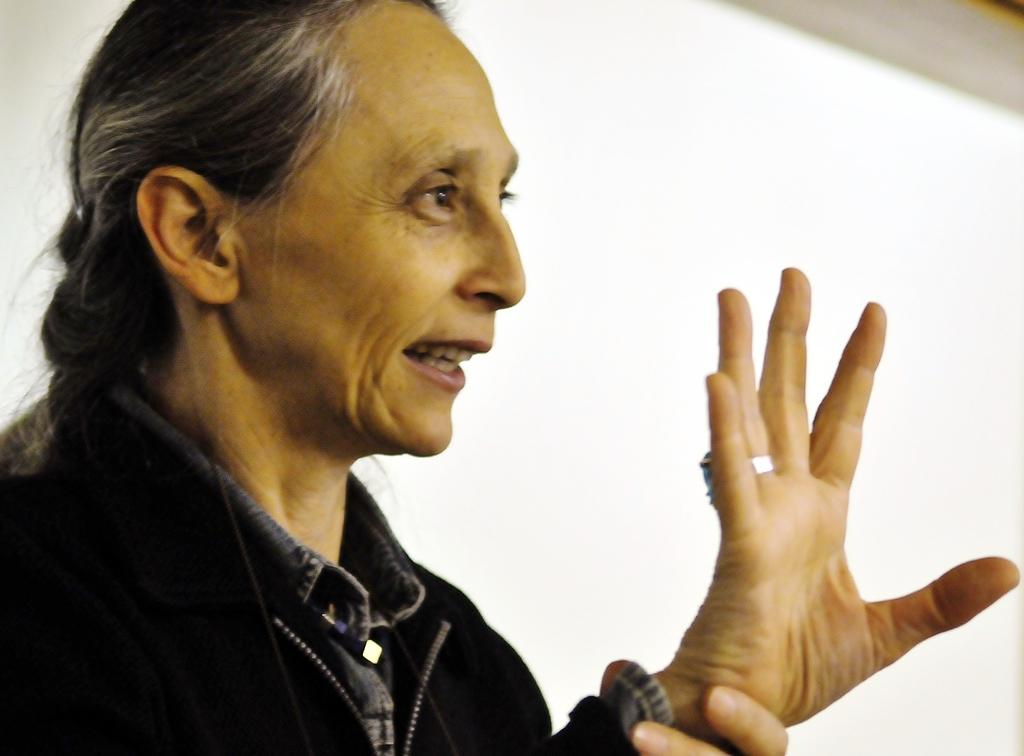Who is the main subject in the foreground of the image? There is a lady in the foreground of the image. What type of basketball game is the woman participating in the image? There is no basketball game or woman participating in a game present in the image; it only features a lady in the foreground. 